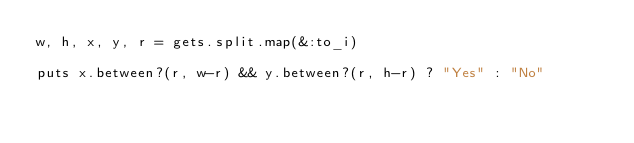Convert code to text. <code><loc_0><loc_0><loc_500><loc_500><_Ruby_>w, h, x, y, r = gets.split.map(&:to_i)

puts x.between?(r, w-r) && y.between?(r, h-r) ? "Yes" : "No"
</code> 